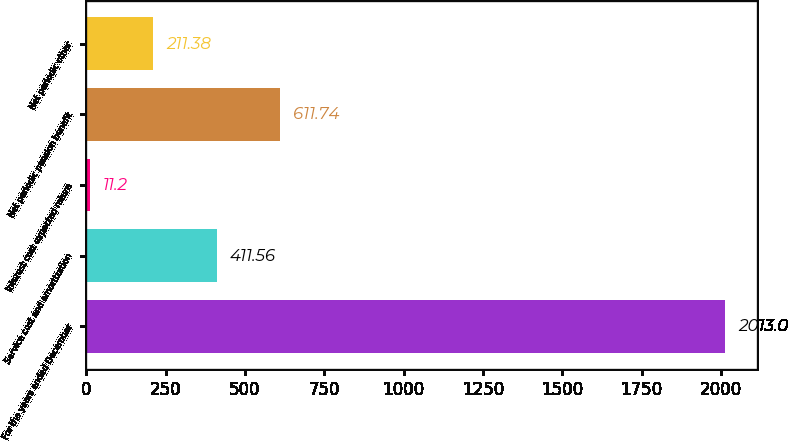Convert chart. <chart><loc_0><loc_0><loc_500><loc_500><bar_chart><fcel>For the years ended December<fcel>Service cost and amortization<fcel>Interest cost expected return<fcel>Net periodic pension benefit<fcel>Net periodic other<nl><fcel>2013<fcel>411.56<fcel>11.2<fcel>611.74<fcel>211.38<nl></chart> 